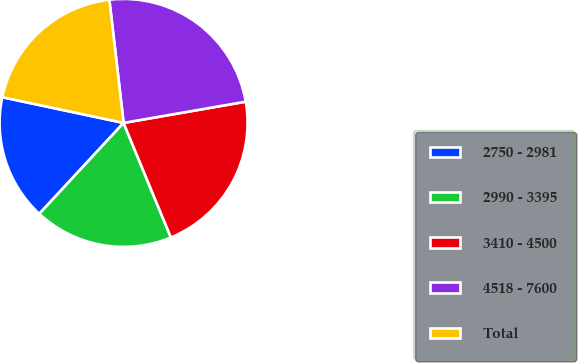<chart> <loc_0><loc_0><loc_500><loc_500><pie_chart><fcel>2750 - 2981<fcel>2990 - 3395<fcel>3410 - 4500<fcel>4518 - 7600<fcel>Total<nl><fcel>16.43%<fcel>18.13%<fcel>21.51%<fcel>24.09%<fcel>19.84%<nl></chart> 